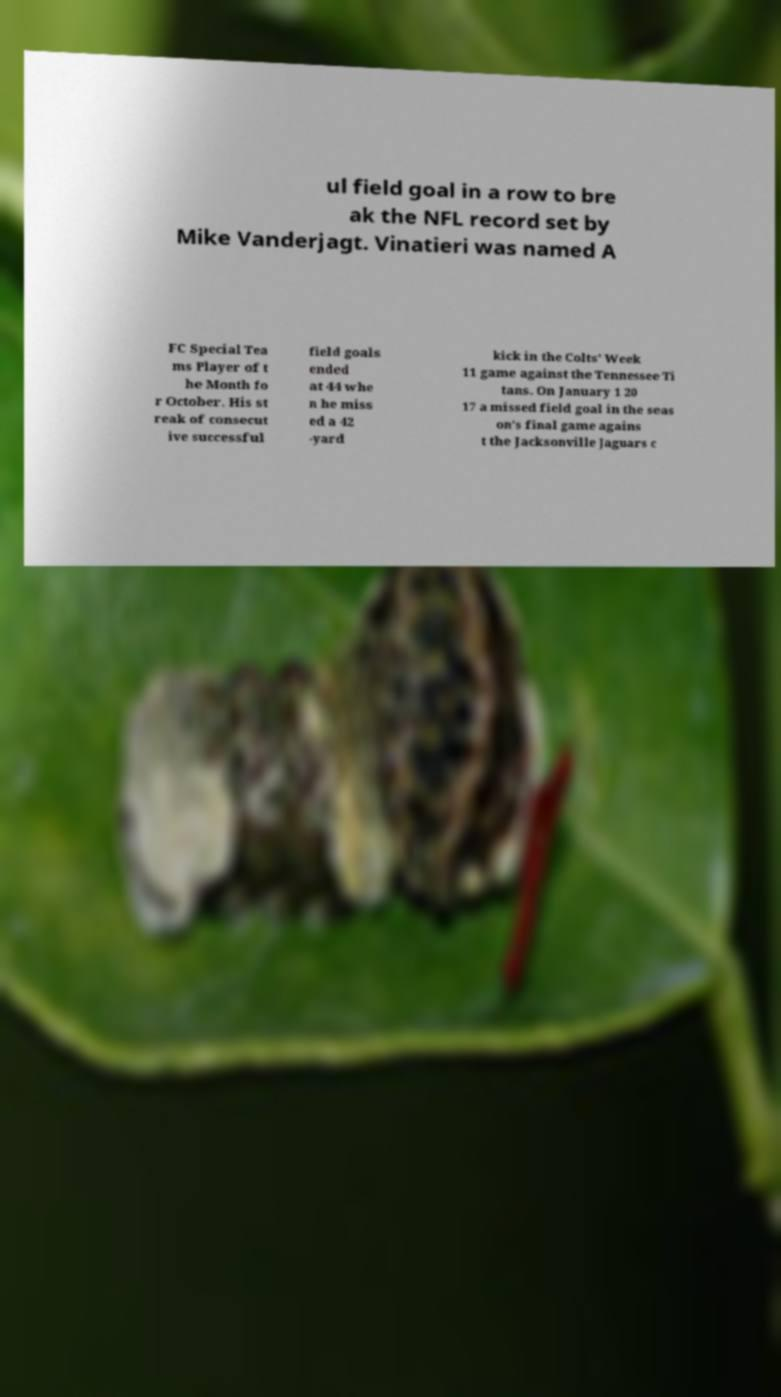Could you extract and type out the text from this image? ul field goal in a row to bre ak the NFL record set by Mike Vanderjagt. Vinatieri was named A FC Special Tea ms Player of t he Month fo r October. His st reak of consecut ive successful field goals ended at 44 whe n he miss ed a 42 -yard kick in the Colts' Week 11 game against the Tennessee Ti tans. On January 1 20 17 a missed field goal in the seas on's final game agains t the Jacksonville Jaguars c 